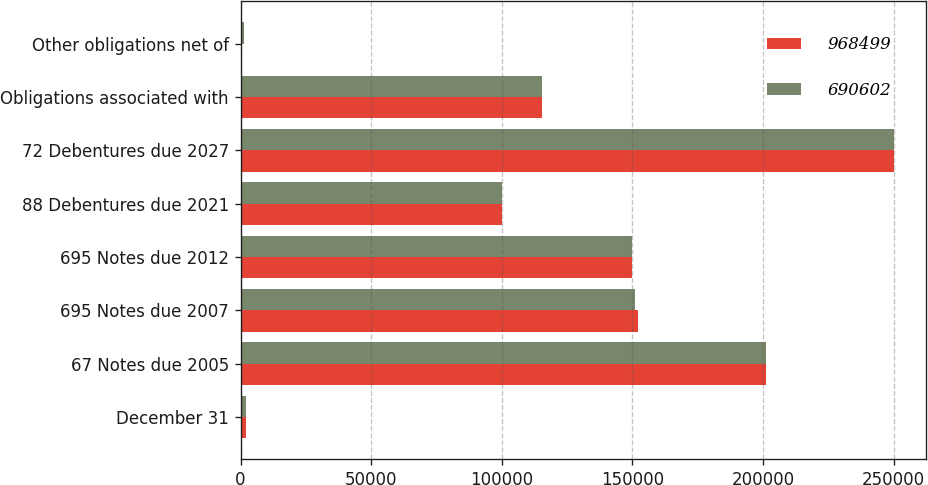Convert chart to OTSL. <chart><loc_0><loc_0><loc_500><loc_500><stacked_bar_chart><ecel><fcel>December 31<fcel>67 Notes due 2005<fcel>695 Notes due 2007<fcel>695 Notes due 2012<fcel>88 Debentures due 2021<fcel>72 Debentures due 2027<fcel>Obligations associated with<fcel>Other obligations net of<nl><fcel>968499<fcel>2004<fcel>201187<fcel>152184<fcel>150000<fcel>100000<fcel>250000<fcel>115544<fcel>730<nl><fcel>690602<fcel>2003<fcel>201058<fcel>151136<fcel>150000<fcel>100000<fcel>250000<fcel>115544<fcel>1238<nl></chart> 